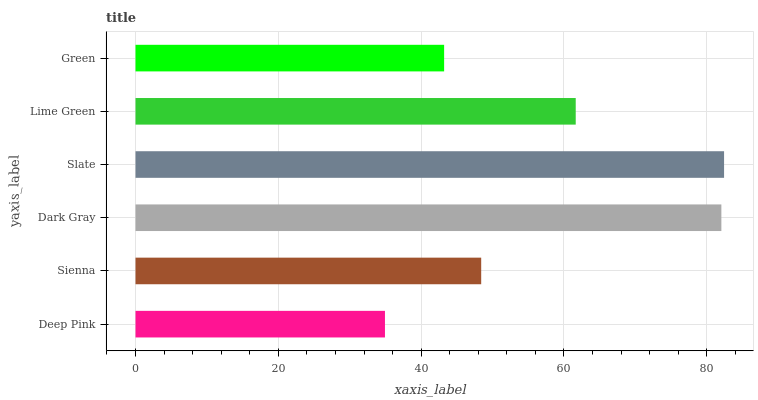Is Deep Pink the minimum?
Answer yes or no. Yes. Is Slate the maximum?
Answer yes or no. Yes. Is Sienna the minimum?
Answer yes or no. No. Is Sienna the maximum?
Answer yes or no. No. Is Sienna greater than Deep Pink?
Answer yes or no. Yes. Is Deep Pink less than Sienna?
Answer yes or no. Yes. Is Deep Pink greater than Sienna?
Answer yes or no. No. Is Sienna less than Deep Pink?
Answer yes or no. No. Is Lime Green the high median?
Answer yes or no. Yes. Is Sienna the low median?
Answer yes or no. Yes. Is Slate the high median?
Answer yes or no. No. Is Lime Green the low median?
Answer yes or no. No. 